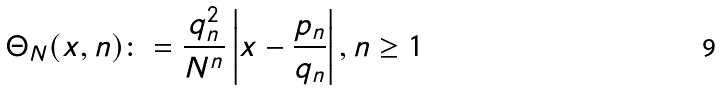Convert formula to latex. <formula><loc_0><loc_0><loc_500><loc_500>\Theta _ { N } ( x , n ) \colon = \frac { q _ { n } ^ { 2 } } { N ^ { n } } \left | x - \frac { p _ { n } } { q _ { n } } \right | , n \geq 1</formula> 